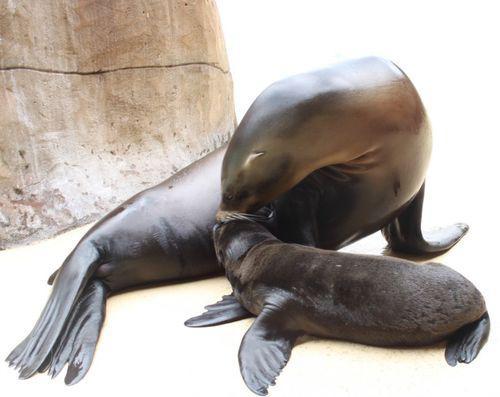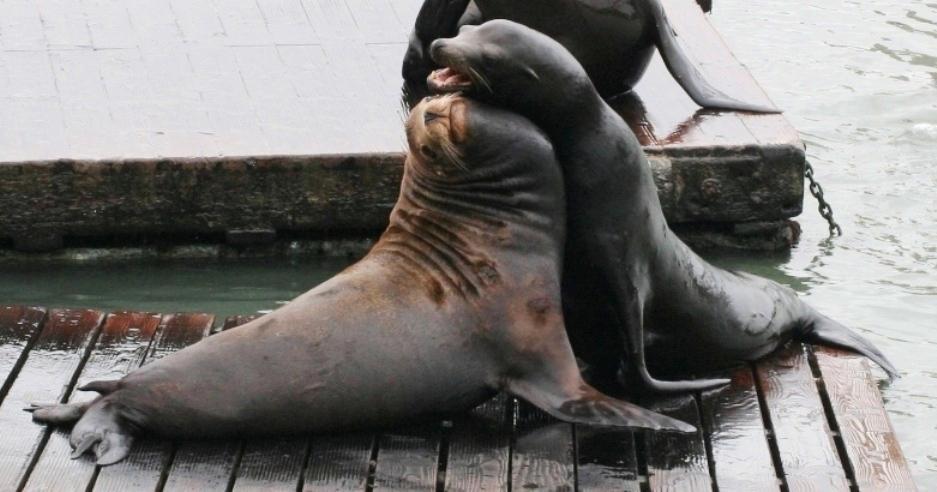The first image is the image on the left, the second image is the image on the right. For the images shown, is this caption "An adult seal to the right of a baby seal extends its neck to touch noses with the smaller animal." true? Answer yes or no. No. 